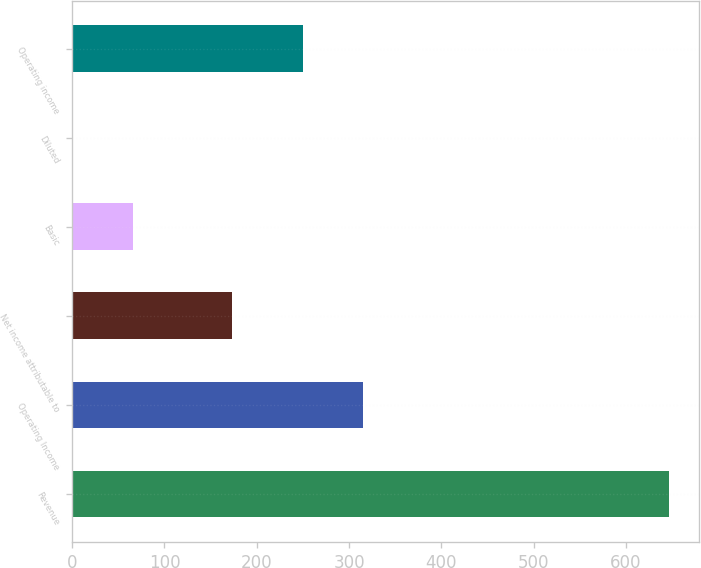Convert chart to OTSL. <chart><loc_0><loc_0><loc_500><loc_500><bar_chart><fcel>Revenue<fcel>Operating Income<fcel>Net income attributable to<fcel>Basic<fcel>Diluted<fcel>Operating income<nl><fcel>646.8<fcel>314.7<fcel>173.5<fcel>65.36<fcel>0.76<fcel>250.1<nl></chart> 